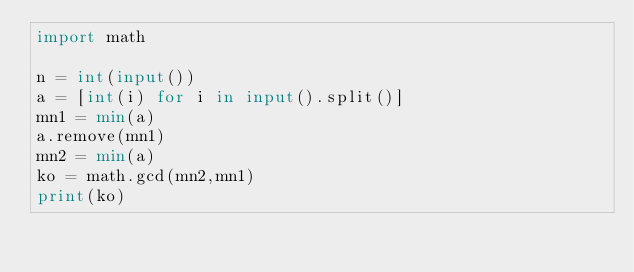<code> <loc_0><loc_0><loc_500><loc_500><_Python_>import math

n = int(input())
a = [int(i) for i in input().split()]
mn1 = min(a)
a.remove(mn1)
mn2 = min(a)
ko = math.gcd(mn2,mn1)
print(ko)</code> 